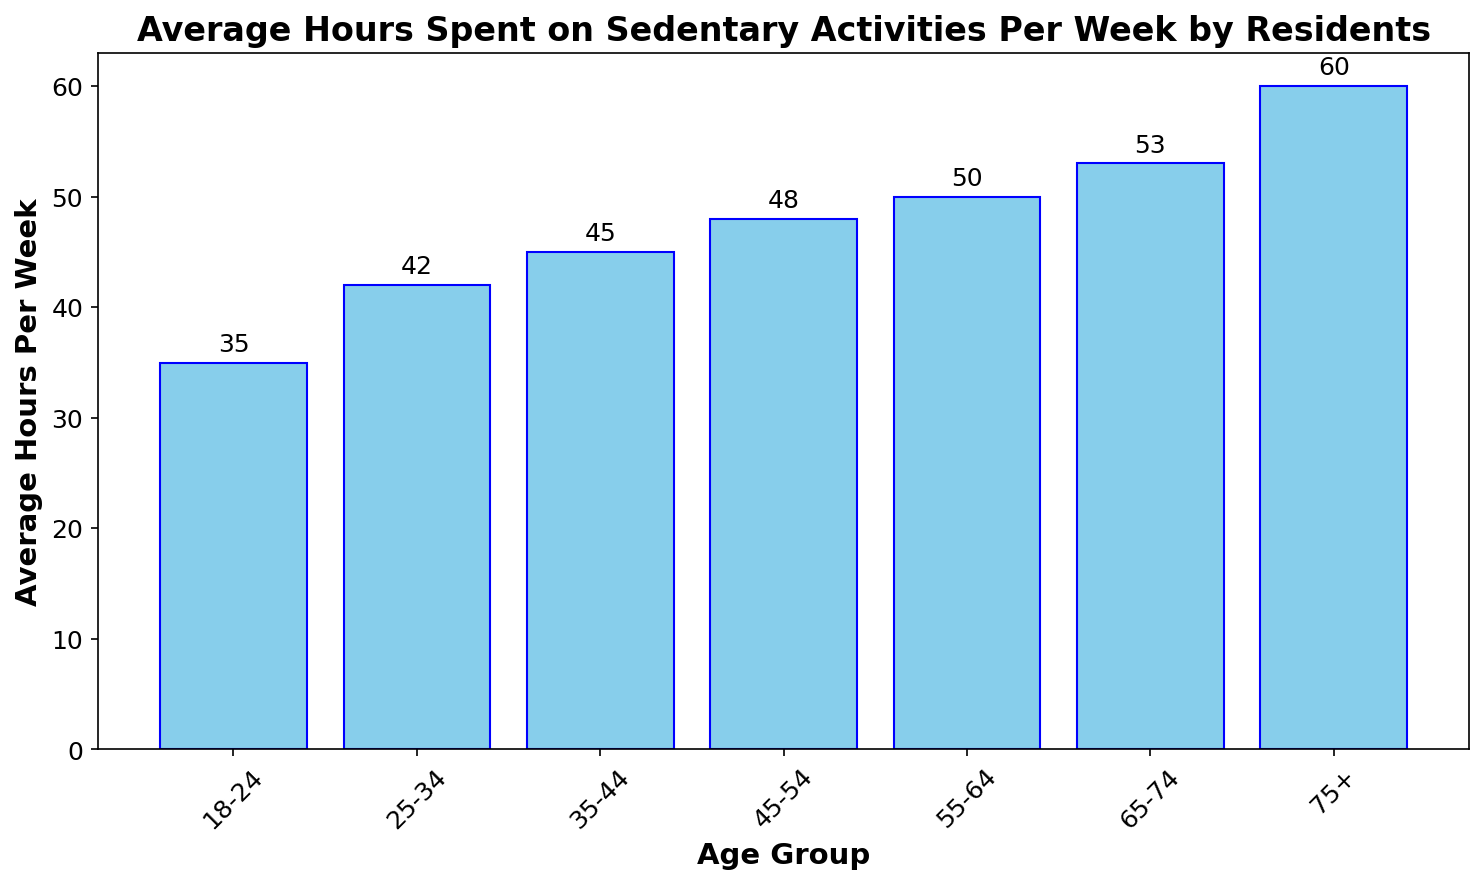What's the age group with the highest average hours spent on sedentary activities? Observing the height of the bars, the "75+" age group has the highest bar, indicating that this group spends the most time on sedentary activities.
Answer: 75+ Which age group spends the least amount of time on sedentary activities per week? The shortest bar in the chart corresponds to the "18-24" age group, meaning they spend the least amount of time on sedentary activities per week.
Answer: 18-24 What is the difference in average hours spent on sedentary activities between the "55-64" and "65-74" age groups? The bar heights show "55-64" at 50 hours and "65-74" at 53 hours. The difference is 53 - 50.
Answer: 3 hours How much more time does the "75+" age group spend on sedentary activities compared to the "18-24" age group per week? The bar heights indicate "75+" at 60 hours and "18-24" at 35 hours. The difference is 60 - 35.
Answer: 25 hours What is the average amount of time spent on sedentary activities across all age groups? Summing the hours from each age group (35 + 42 + 45 + 48 + 50 + 53 + 60) and dividing by the number of groups (7), we get (333 / 7).
Answer: 47.57 hours Which two age groups have the closest average hours spent on sedentary activities? By comparing the bar heights, "45-54" (48 hours) and "55-64" (50 hours) are the closest with a difference of only 2 hours.
Answer: 45-54 and 55-64 How many more hours do residents aged "55-64" spend on sedentary activities compared to those aged "35-44"? The bar heights show "55-64" at 50 hours and "35-44" at 45 hours. The difference is 50 - 45.
Answer: 5 hours Which age group saw a 7-hour increase in sedentary activities compared to the "18-24" group? The "18-24" group spends 35 hours, so looking for an age group spending 35 + 7 = 42 hours, we find the "25-34" group.
Answer: 25-34 What is the sum of the average hours spent on sedentary activities for the "18-24" and "75+" age groups? The "18-24" age group spends 35 hours and the "75+" age group spends 60 hours. Summing these gives 35 + 60.
Answer: 95 hours Is the average number of hours spent on sedentary activities higher for residents aged "35-44" than for those aged "25-34"? The bar heights show "35-44" at 45 hours and "25-34" at 42 hours. So, 45 is greater than 42.
Answer: Yes 